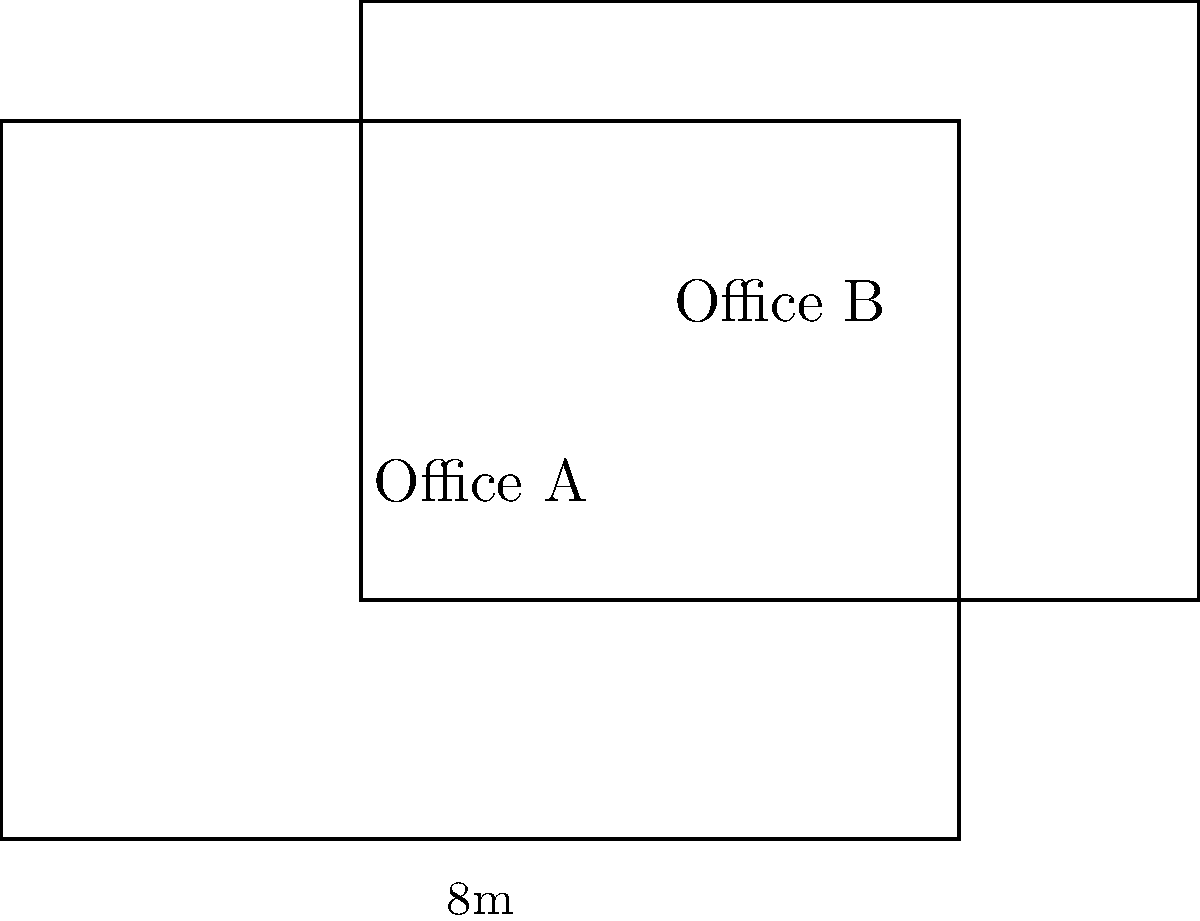In a shared office building, two rectangular office spaces overlap as shown in the diagram. Office A measures 8m by 6m, while Office B measures 7m by 5m. The bottom-left corner of the overlapping area is at coordinates (3,2), and the top-right corner is at (8,6). Calculate the area of the overlapping space that both offices share. How might this information be relevant in negotiating a lease agreement for either office? To calculate the area of the overlapping space, we need to follow these steps:

1. Identify the dimensions of the overlapping rectangle:
   - Width: $8m - 3m = 5m$
   - Height: $6m - 2m = 4m$

2. Calculate the area of the overlapping rectangle:
   $Area = width \times height$
   $Area = 5m \times 4m = 20m^2$

3. Relevance to lease negotiation:
   - The overlapping area represents shared space, which could affect the usable area of each office.
   - This information could be used to:
     a) Adjust the rent proportionally based on exclusive and shared space.
     b) Negotiate terms for using the shared area (e.g., scheduling, maintenance responsibilities).
     c) Determine if privacy concerns arise from the overlap and discuss potential solutions.
     d) Calculate the effective private space for each office, which could influence the overall value of the lease.

By understanding the exact measurements of the overlap, both parties can engage in more informed negotiations, ensuring a fair agreement that accounts for the unique layout of the shared space.
Answer: $20m^2$; crucial for fair rent calculation and usage terms in lease negotiation. 